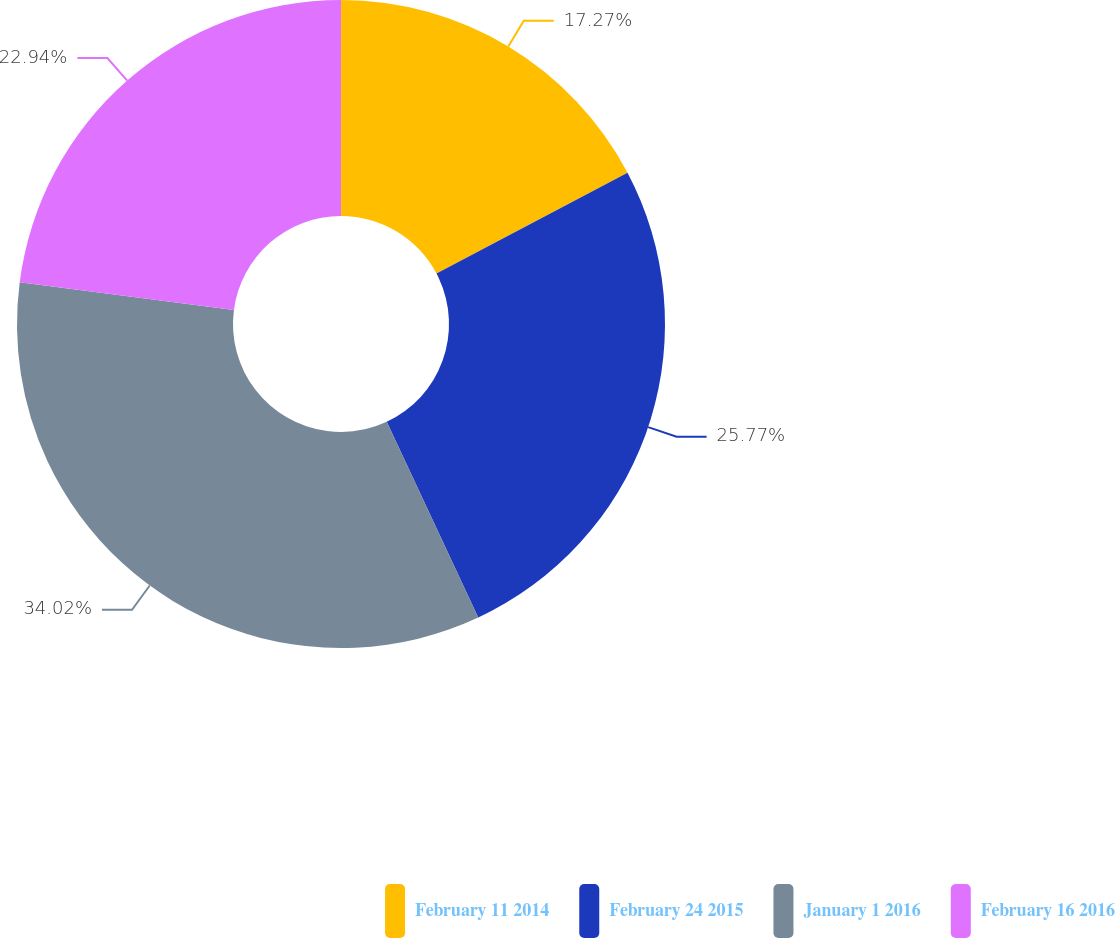<chart> <loc_0><loc_0><loc_500><loc_500><pie_chart><fcel>February 11 2014<fcel>February 24 2015<fcel>January 1 2016<fcel>February 16 2016<nl><fcel>17.27%<fcel>25.77%<fcel>34.02%<fcel>22.94%<nl></chart> 